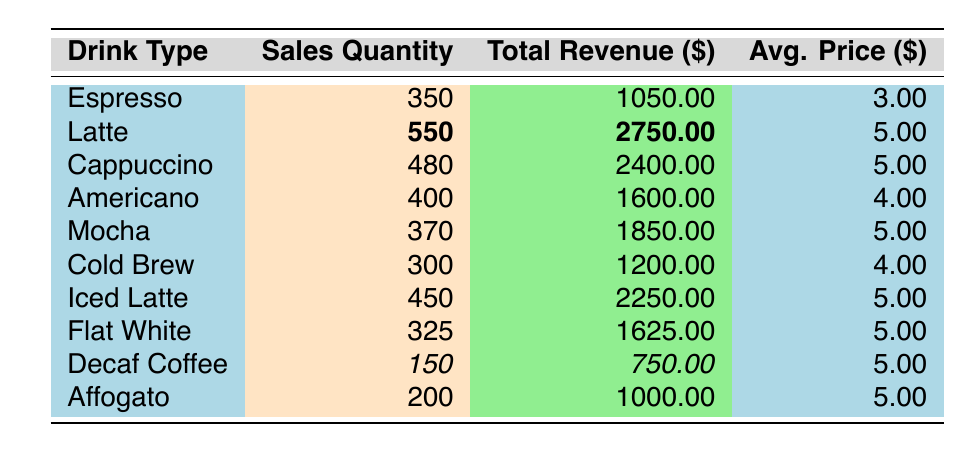What drink type had the highest sales quantity? The table indicates that the Latte has the highest sales quantity, shown by the bold value of 550.
Answer: Latte What was the total revenue generated from Cappuccino sales? The total revenue generated from Cappuccino sales can be found directly in the table, which shows a revenue of 2400.00.
Answer: 2400.00 How many more units of Iced Lattes were sold compared to Cold Brew? The Iced Latte sales quantity is 450 and Cold Brew is 300. The difference is 450 - 300 = 150.
Answer: 150 Is the average price of Decaf Coffee higher than 5.00? The average price of Decaf Coffee is shown as 5.00, which is not higher than 5.00.
Answer: No What drink types generated a total revenue of more than $2000? The table shows total revenues: Latte (2750.00), Cappuccino (2400.00), and Iced Latte (2250.00), which are all above $2000.
Answer: Latte, Cappuccino, Iced Latte What was the average revenue generated per drink type? To find the average revenue, sum all total revenues: 1050 + 2750 + 2400 + 1600 + 1850 + 1200 + 2250 + 1625 + 750 + 1000 = 14,825, then divide by 10 (number of drink types) giving 1482.5.
Answer: 1482.50 Which drink type had the lowest sales quantity? The table shows that Decaf Coffee had the lowest sales quantity of 150, marked in italics.
Answer: Decaf Coffee How much more revenue did Latte generate compared to Espresso? The total revenue for Latte is 2750.00 and for Espresso it is 1050.00. The difference is 2750.00 - 1050.00 = 1700.00.
Answer: 1700.00 What is the average price of beverages that sold more than 400 units? The drink types that sold more than 400 units are Latte (5.00), Cappuccino (5.00), Americano (4.00), and Iced Latte (5.00). Their average price is (5.00 + 5.00 + 4.00 + 5.00) / 4 = 4.75.
Answer: 4.75 Which drink types had identical average prices, and what is that price? The drink types with identical average prices are Latte, Cappuccino, Mocha, Iced Latte, Flat White, and Affogato, all priced at 5.00.
Answer: 5.00 